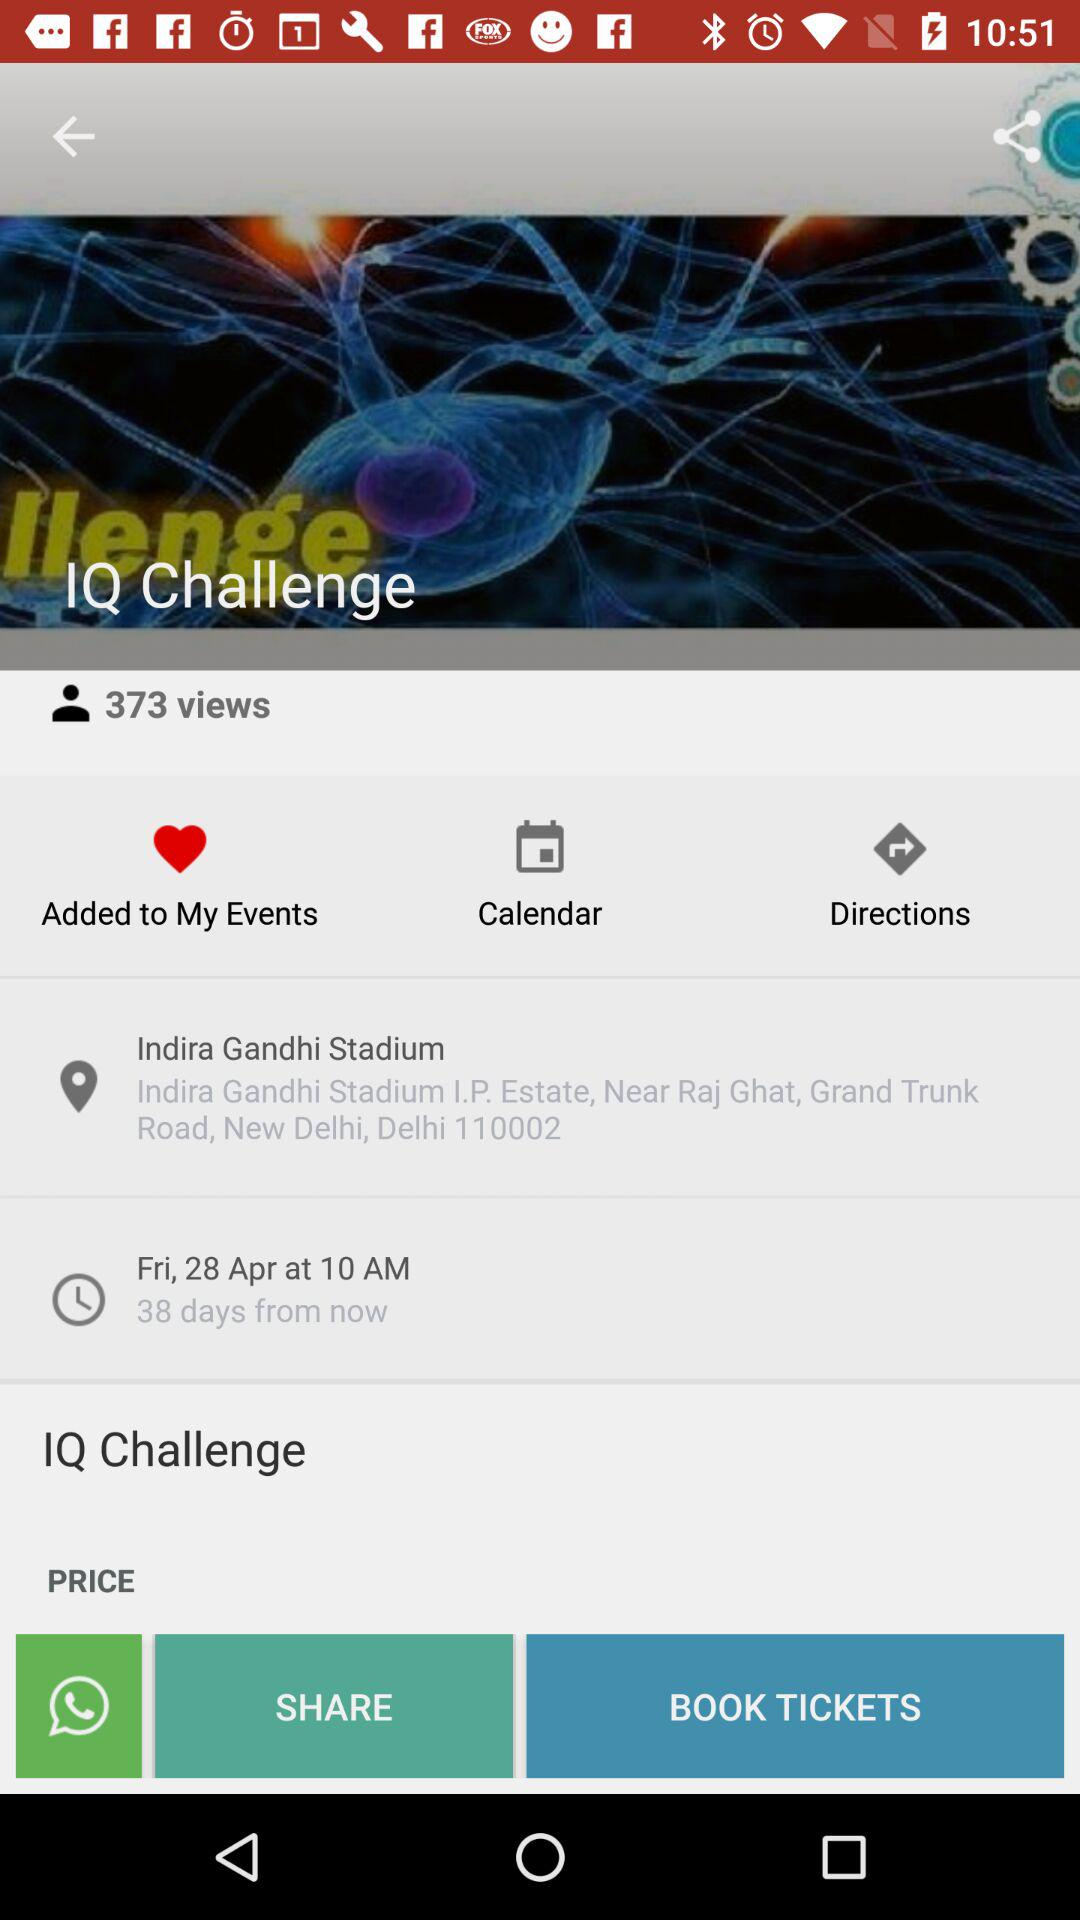How many days are left from now? There are 38 days left from now. 